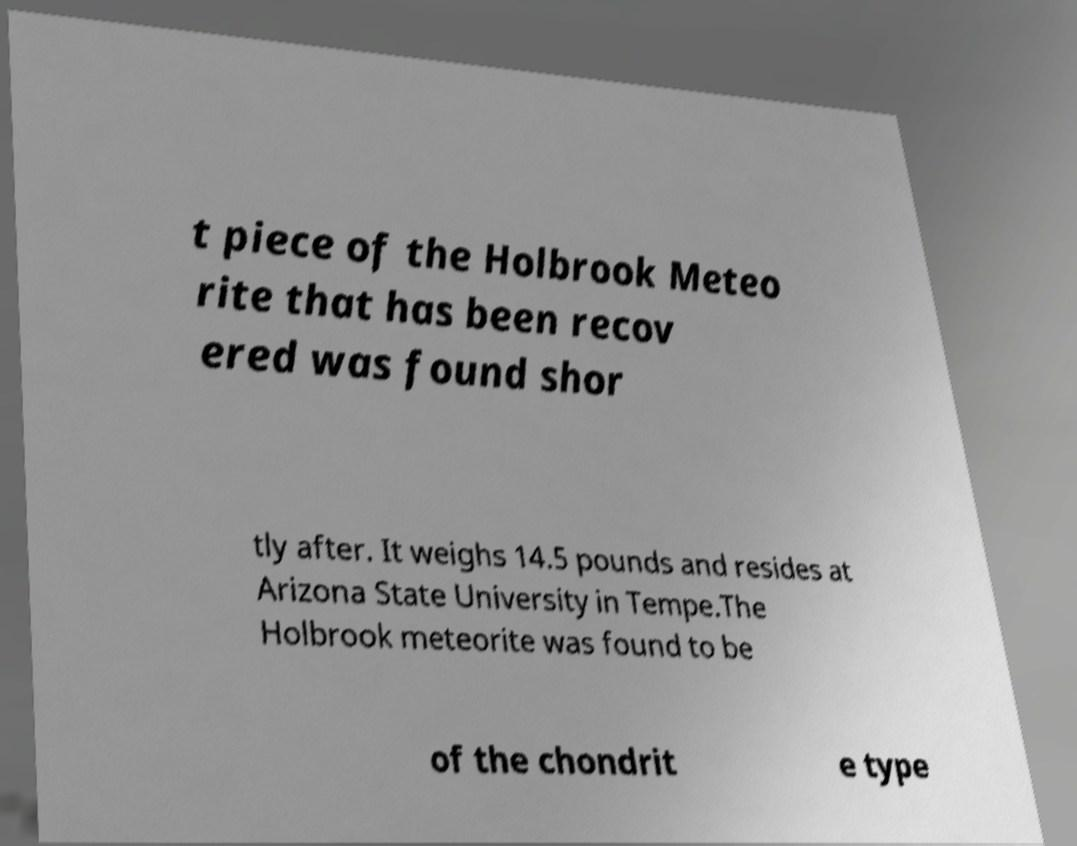Could you assist in decoding the text presented in this image and type it out clearly? t piece of the Holbrook Meteo rite that has been recov ered was found shor tly after. It weighs 14.5 pounds and resides at Arizona State University in Tempe.The Holbrook meteorite was found to be of the chondrit e type 